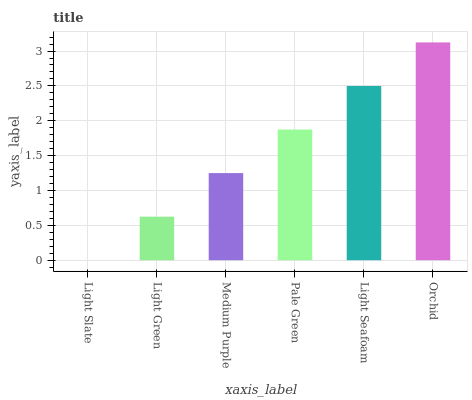Is Light Slate the minimum?
Answer yes or no. Yes. Is Orchid the maximum?
Answer yes or no. Yes. Is Light Green the minimum?
Answer yes or no. No. Is Light Green the maximum?
Answer yes or no. No. Is Light Green greater than Light Slate?
Answer yes or no. Yes. Is Light Slate less than Light Green?
Answer yes or no. Yes. Is Light Slate greater than Light Green?
Answer yes or no. No. Is Light Green less than Light Slate?
Answer yes or no. No. Is Pale Green the high median?
Answer yes or no. Yes. Is Medium Purple the low median?
Answer yes or no. Yes. Is Orchid the high median?
Answer yes or no. No. Is Light Slate the low median?
Answer yes or no. No. 